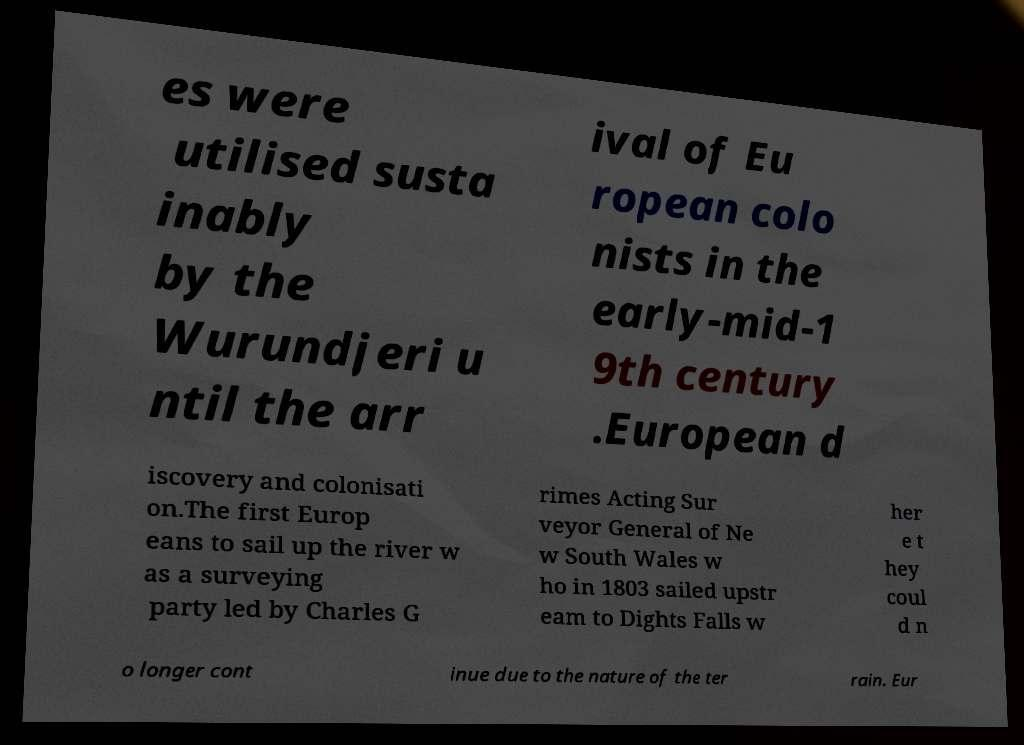What messages or text are displayed in this image? I need them in a readable, typed format. es were utilised susta inably by the Wurundjeri u ntil the arr ival of Eu ropean colo nists in the early-mid-1 9th century .European d iscovery and colonisati on.The first Europ eans to sail up the river w as a surveying party led by Charles G rimes Acting Sur veyor General of Ne w South Wales w ho in 1803 sailed upstr eam to Dights Falls w her e t hey coul d n o longer cont inue due to the nature of the ter rain. Eur 